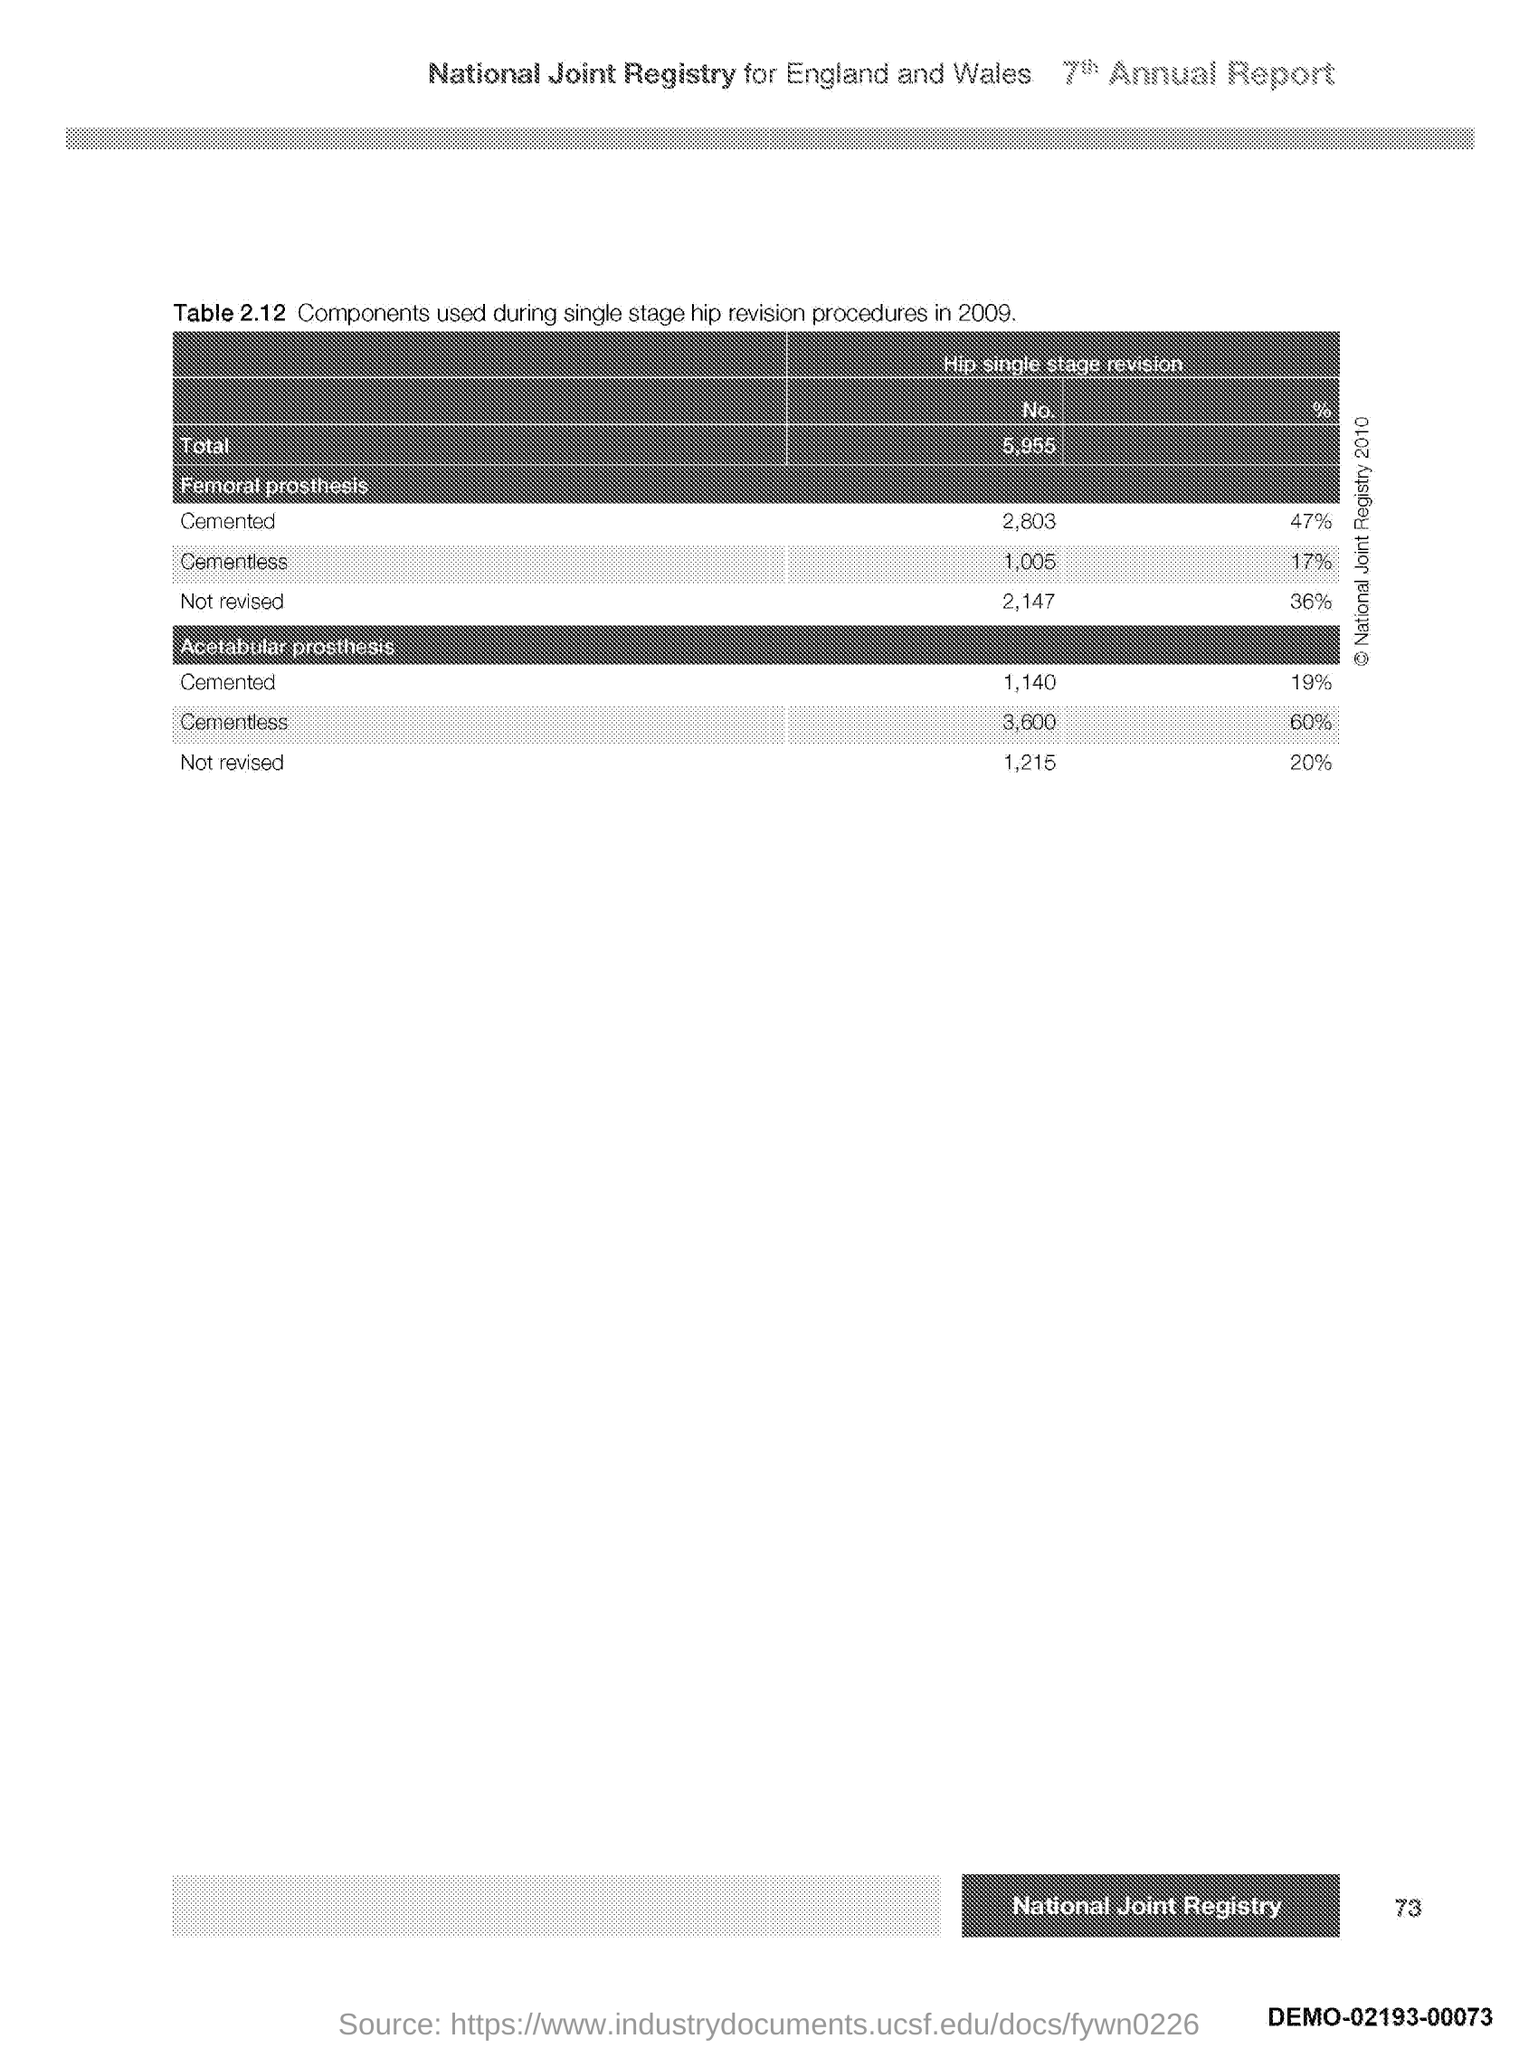What is the Page Number?
Ensure brevity in your answer.  73. 